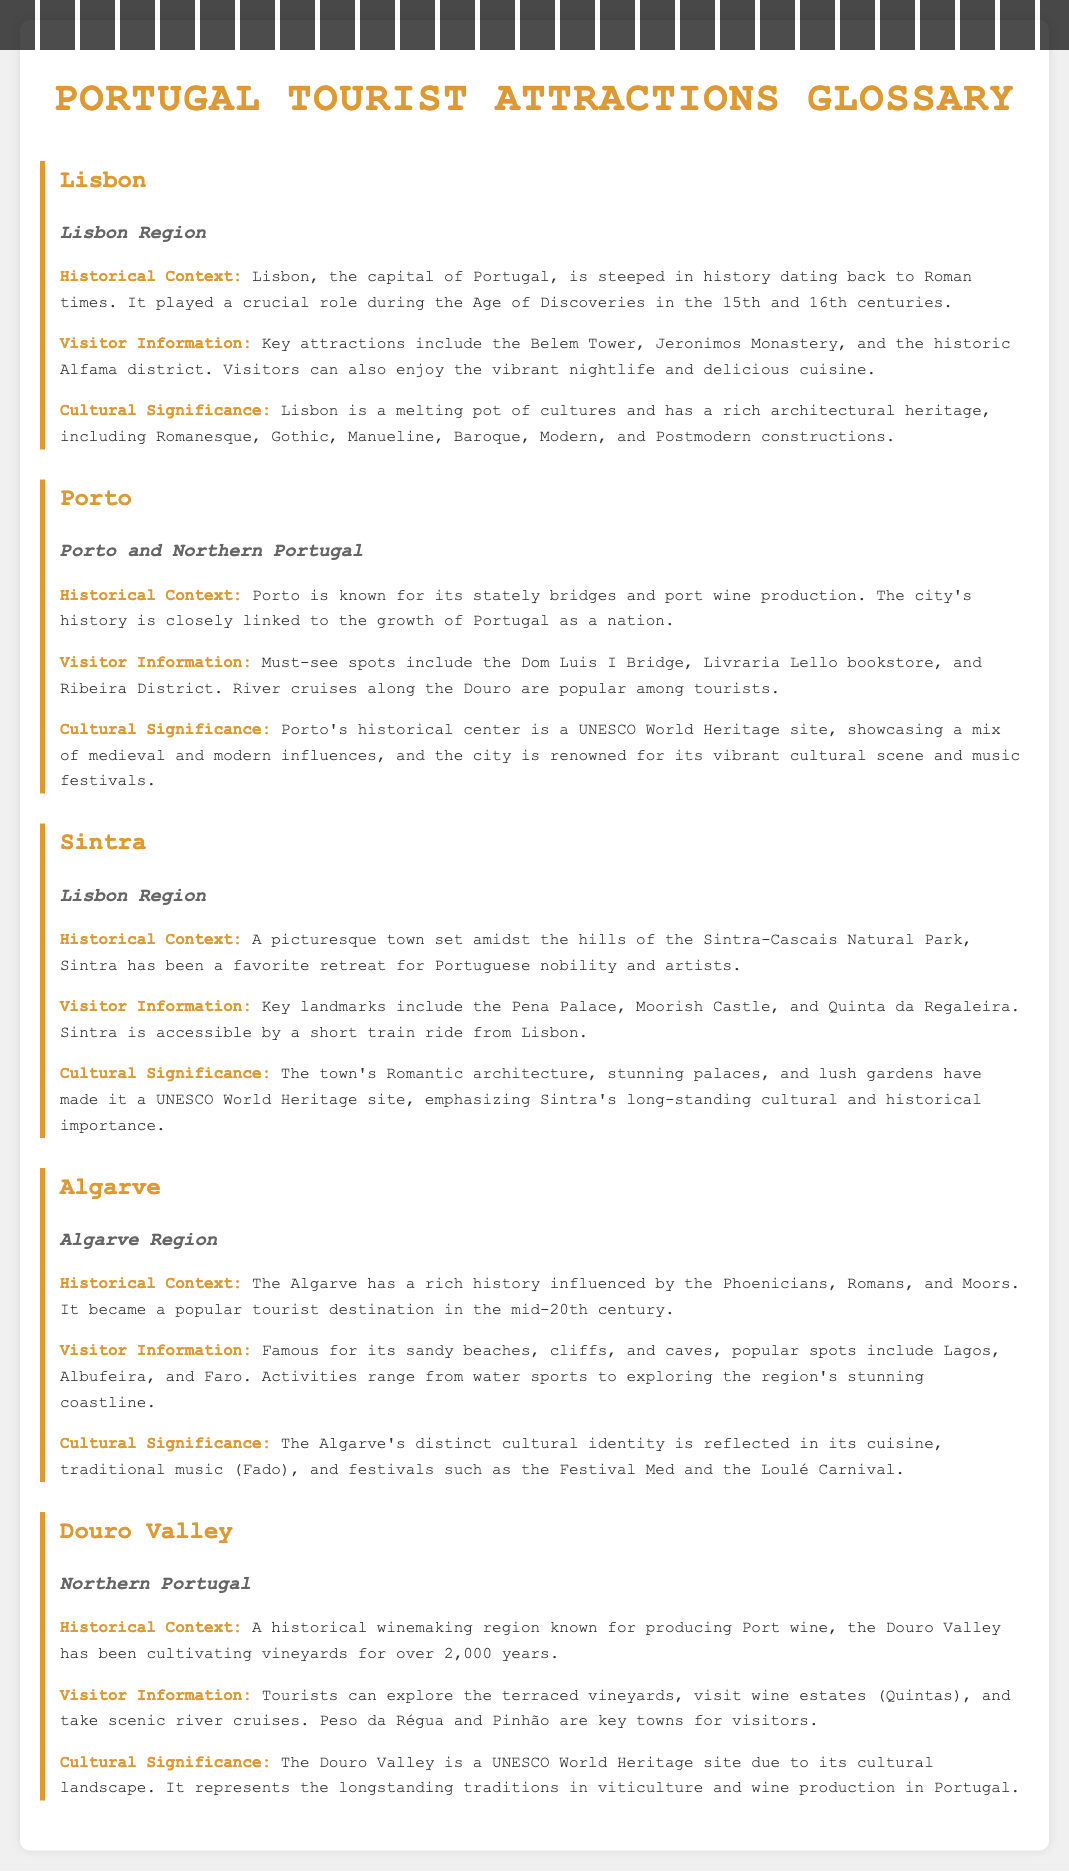What is the capital of Portugal? The document identifies Lisbon as the capital of Portugal.
Answer: Lisbon Which region is Sintra located in? The document specifies that Sintra is in the Lisbon Region.
Answer: Lisbon Region What UNESCO World Heritage site is mentioned in relation to Porto? The document states that Porto's historical center is a UNESCO World Heritage site.
Answer: UNESCO World Heritage site What is a popular activity in the Algarve? The document mentions various activities, including water sports, as popular in the Algarve.
Answer: Water sports How long has the Douro Valley been cultivating vineyards? The document indicates that the Douro Valley has been cultivating vineyards for over 2,000 years.
Answer: Over 2,000 years What is the historical significance of Lisbon? The document notes that Lisbon played a crucial role during the Age of Discoveries.
Answer: Age of Discoveries Which palace is a key landmark in Sintra? The document highlights the Pena Palace as a key landmark in Sintra.
Answer: Pena Palace What type of cuisine is associated with the Algarve? The document mentions that the Algarve's distinct cultural identity is reflected in its cuisine.
Answer: Cuisine What cultural activity is Porto renowned for? According to the document, Porto is renowned for its vibrant cultural scene and music festivals.
Answer: Music festivals 